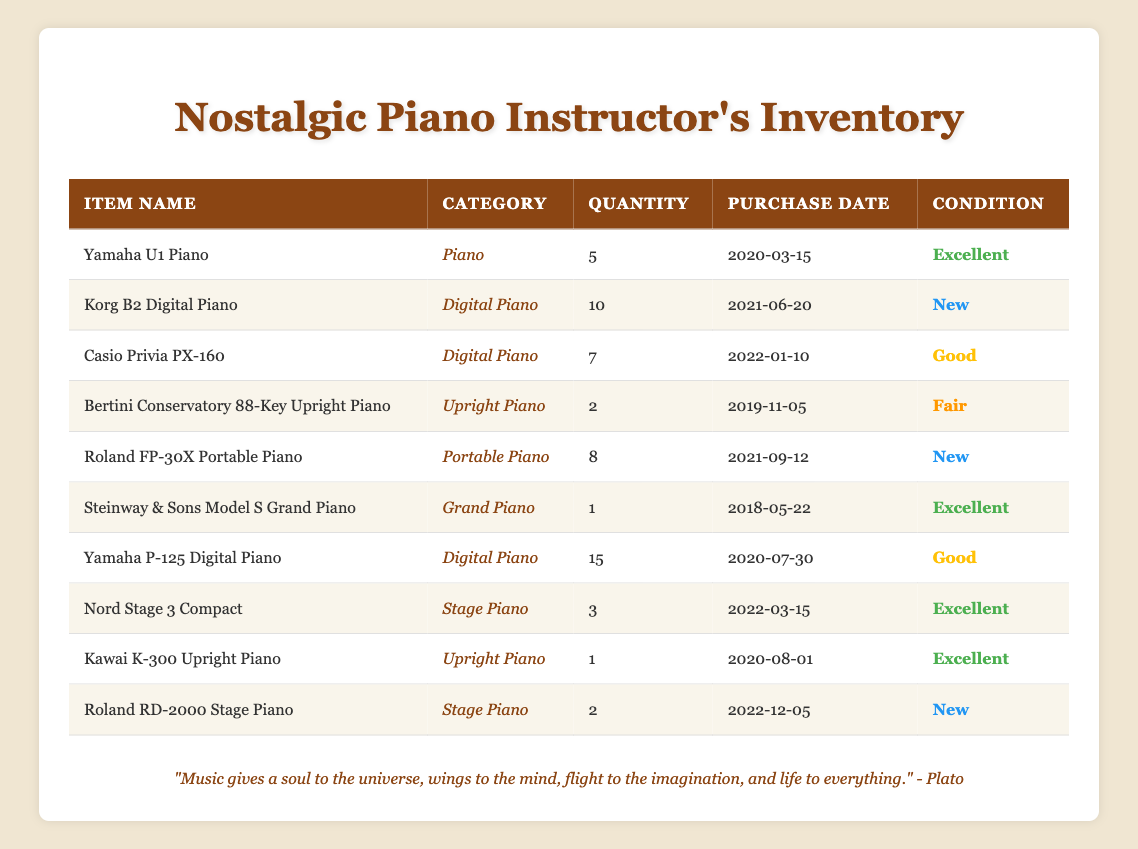What is the total quantity of digital pianos listed in the inventory? To find the total, we identify the items categorized as "Digital Piano" in the table, which are Korg B2 Digital Piano (10), Casio Privia PX-160 (7), and Yamaha P-125 Digital Piano (15). Summing these quantities: 10 + 7 + 15 = 32.
Answer: 32 How many musical instruments are in "Excellent" condition? We count the items with "Excellent" condition: Yamaha U1 Piano (5), Steinway & Sons Model S Grand Piano (1), Nord Stage 3 Compact (3), Kawai K-300 Upright Piano (1). This gives us a total of 5 + 1 + 3 + 1 = 10 instruments.
Answer: 10 Is there a portable piano listed in the inventory? We check the inventory for any item categorized as "Portable Piano." The Roland FP-30X Portable Piano is listed, indicating that there is indeed a portable piano in the inventory.
Answer: Yes What is the purchase date of the Roland RD-2000 Stage Piano? The inventory table lists the Roland RD-2000 Stage Piano with a purchase date of 2022-12-05, which can be found directly in the table under the respective columns.
Answer: 2022-12-05 Which piano has the highest quantity available? To find the piano with the highest quantity, we compare the quantities listed: Yamaha P-125 Digital Piano (15), Korg B2 Digital Piano (10), and others. The Yamaha P-125 has the largest number of 15.
Answer: Yamaha P-125 Digital Piano What is the average quantity of upright pianos in the inventory? There are two upright pianos: Bertini Conservatory 88-Key Upright Piano (2) and Kawai K-300 Upright Piano (1). We find the average by adding their quantities: 2 + 1 = 3, then divide by the number of upright piano entries: 3 / 2 = 1.5.
Answer: 1.5 How many instruments were purchased in the year 2020? We'll check the purchase dates for each item. The items purchased in 2020 are Yamaha U1 Piano (2020-03-15), Yamaha P-125 Digital Piano (2020-07-30), and Kawai K-300 Upright Piano (2020-08-01). This gives us a total of 3 instruments for that year.
Answer: 3 Is there more than one item in "Fair" condition? Looking at the condition column, Bertini Conservatory 88-Key Upright Piano is the only item listed as "Fair." Therefore, there is not more than one item in this condition.
Answer: No 